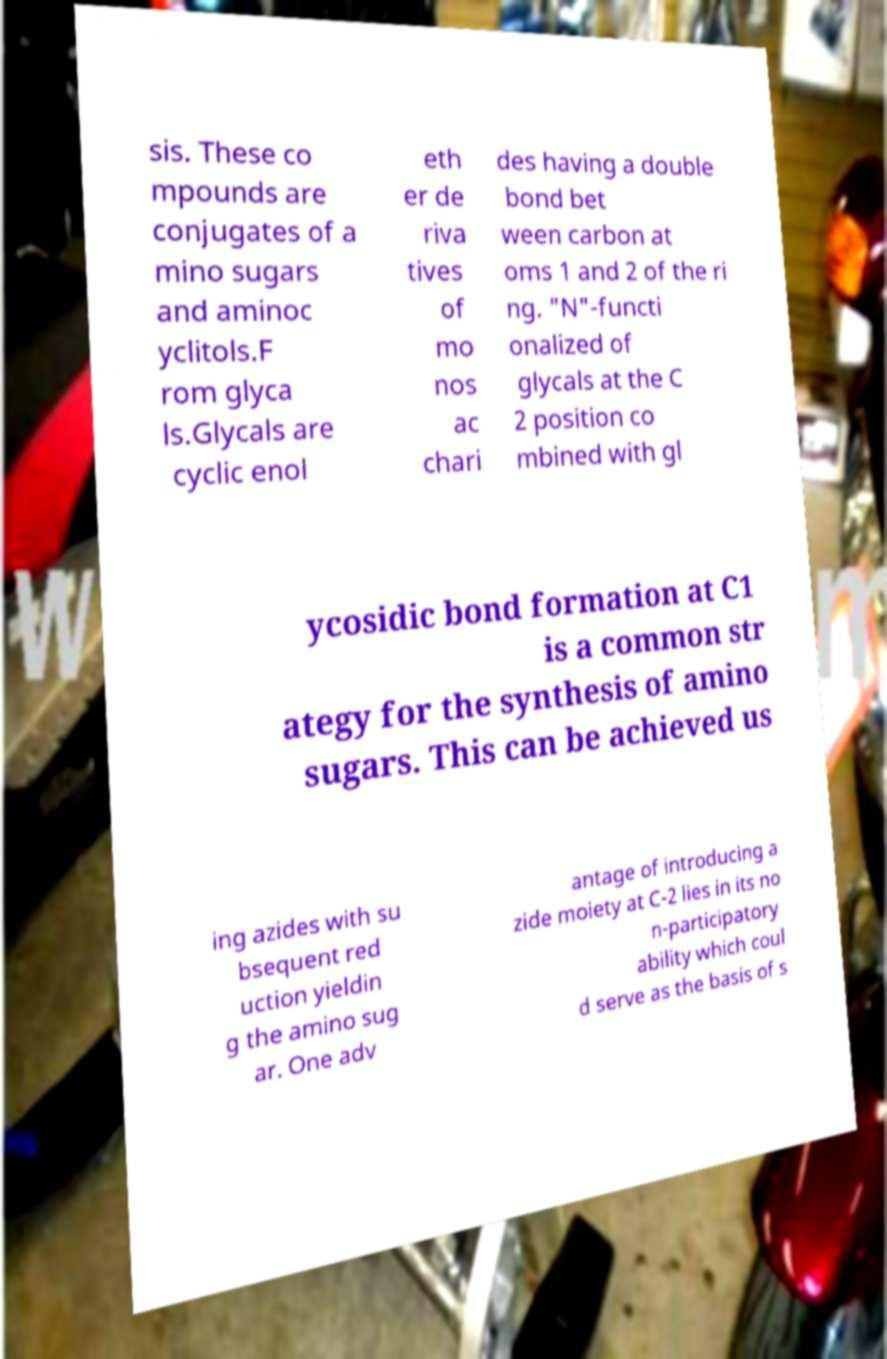Could you assist in decoding the text presented in this image and type it out clearly? sis. These co mpounds are conjugates of a mino sugars and aminoc yclitols.F rom glyca ls.Glycals are cyclic enol eth er de riva tives of mo nos ac chari des having a double bond bet ween carbon at oms 1 and 2 of the ri ng. "N"-functi onalized of glycals at the C 2 position co mbined with gl ycosidic bond formation at C1 is a common str ategy for the synthesis of amino sugars. This can be achieved us ing azides with su bsequent red uction yieldin g the amino sug ar. One adv antage of introducing a zide moiety at C-2 lies in its no n-participatory ability which coul d serve as the basis of s 